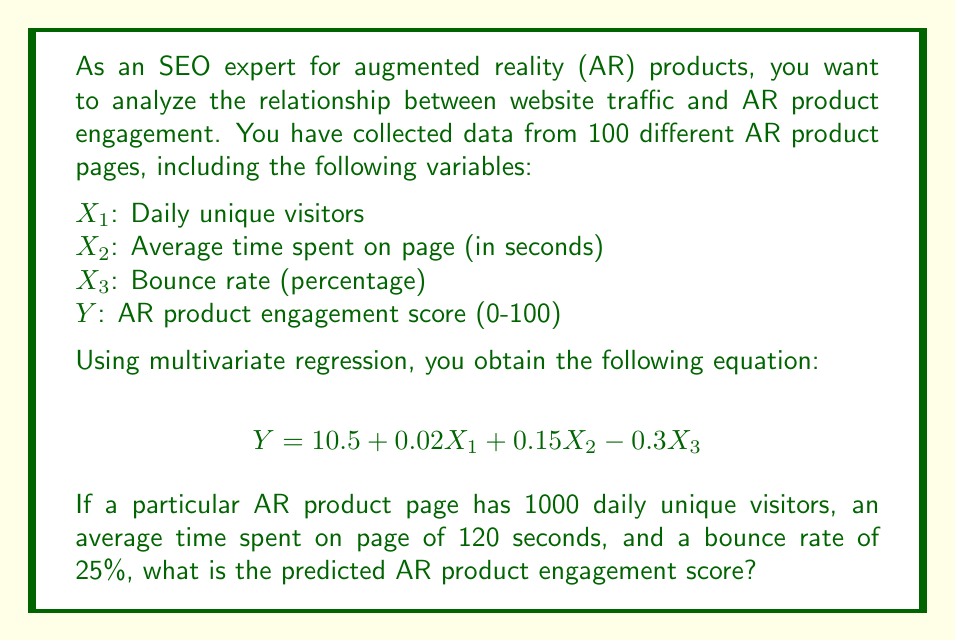Can you answer this question? To solve this problem, we need to follow these steps:

1. Identify the given multivariate regression equation:
   $$Y = 10.5 + 0.02X_1 + 0.15X_2 - 0.3X_3$$

2. Identify the values for each variable:
   $X_1$ (Daily unique visitors) = 1000
   $X_2$ (Average time spent on page) = 120 seconds
   $X_3$ (Bounce rate) = 25%

3. Substitute these values into the equation:
   $$Y = 10.5 + 0.02(1000) + 0.15(120) - 0.3(25)$$

4. Calculate each term:
   - $10.5$ (constant term)
   - $0.02 * 1000 = 20$
   - $0.15 * 120 = 18$
   - $-0.3 * 25 = -7.5$

5. Sum up all the terms:
   $$Y = 10.5 + 20 + 18 - 7.5$$

6. Perform the final calculation:
   $$Y = 41$$

Therefore, the predicted AR product engagement score for this page is 41 out of 100.
Answer: 41 